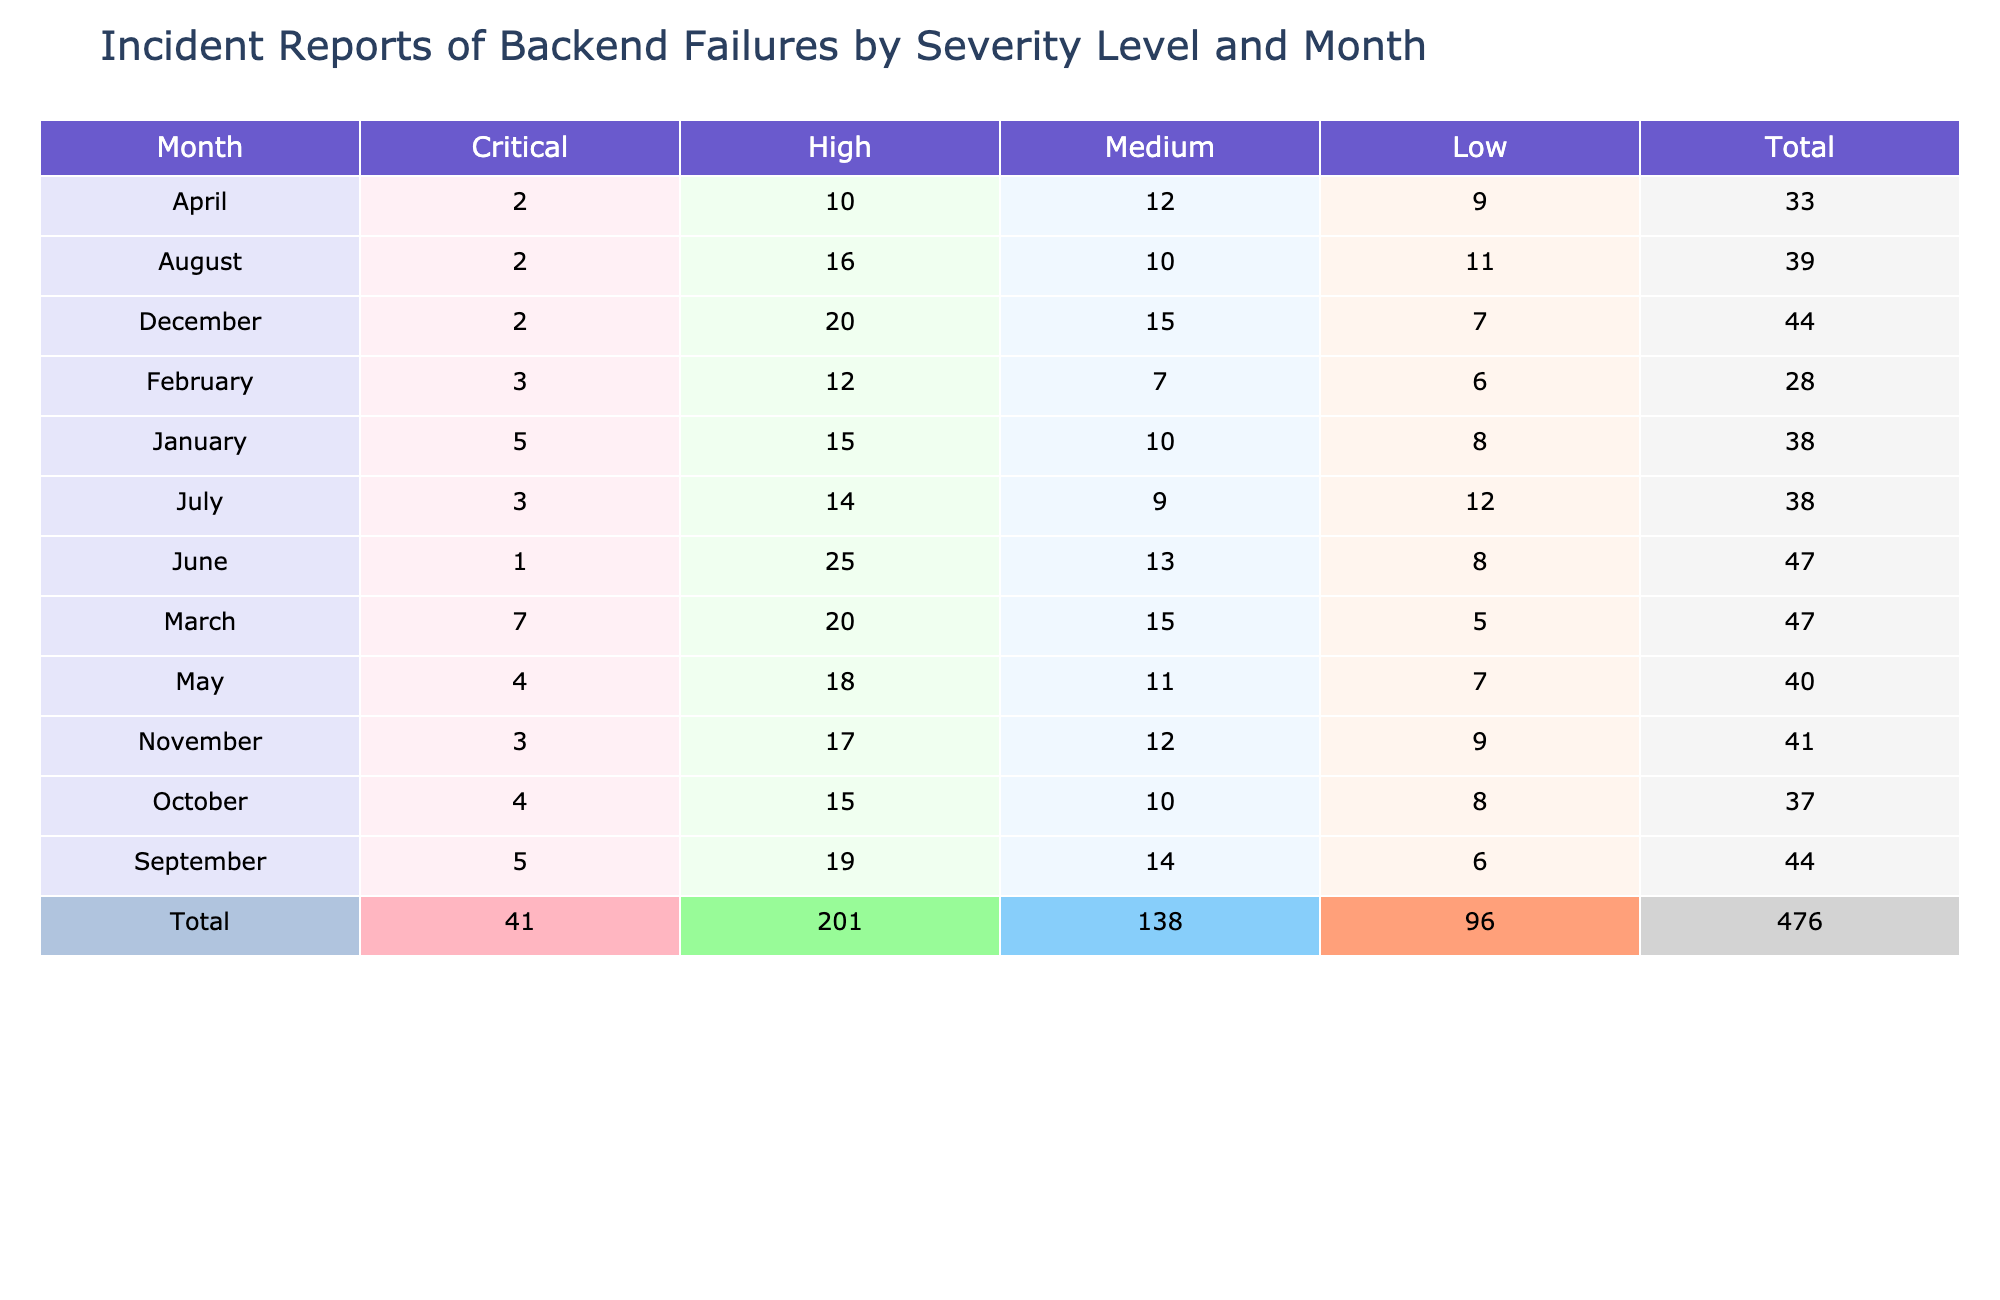What is the total number of Critical incidents reported in March? In March, the Critical incidents reported are 7. This is a direct retrieval of the value from the table, specifically looking at the row for March under the Critical column.
Answer: 7 Which month had the highest number of incidents categorized as High? Looking at the table, June shows the highest number of High incidents, with a count of 25. This is taking the maximum value from the High column across all months.
Answer: 25 What is the total number of incidents across all severity levels for the month of January? For January, the sum of all incident counts is calculated as follows: Critical (5) + High (15) + Medium (10) + Low (8) = 38. Thus, the total incidents in January is 38.
Answer: 38 Did the number of Low incidents increase in July compared to June? In July, the Low incidents reported are 12, while in June they are 8. Since 12 is greater than 8, the number of Low incidents did increase from June to July.
Answer: Yes What is the average number of Medium incidents reported from February to April? The Medium incidents reported for February (7), March (15), and April (12) sum to 34. The average is calculated by dividing the total by the number of months, 34 / 3 = 11.33. Thus, the average number of Medium incidents is approximately 11.33.
Answer: 11.33 Which month had the lowest total number of incidents, and what was that total? Looking at the total incidents for each month, January has a total of 38, February 28, March 57, April 43, May 40, June 67, July 38, August 39, September 44, October 37, November 41, and December 44. The lowest total is in February with 28.
Answer: February, 28 How many total Critical incidents were reported from January to May? The total Critical incidents from January (5), February (3), March (7), April (2), and May (4) can be summed as 5 + 3 + 7 + 2 + 4 = 21. Therefore, the total number of Critical incidents reported from January to May is 21.
Answer: 21 Is the average number of High incidents for the last quarter higher than that for the first quarter? For the last quarter (October, November, December), the High incidents are: October (15), November (17), December (20), summing to 52, averaging 52/3 = 17.33. For the first quarter (January, February, March), the High incidents are: January (15), February (12), March (20), summing to 47, averaging 47/3 = 15.67. Since 17.33 > 15.67, the average for the last quarter is indeed higher.
Answer: Yes What is the difference in the total number of incidents between the month with the highest total and the month with the lowest total? The month with the highest total incidents is June with 67 and the month with the lowest is February with 28. The difference is 67 - 28 = 39. Therefore, the difference in total incidents is 39.
Answer: 39 